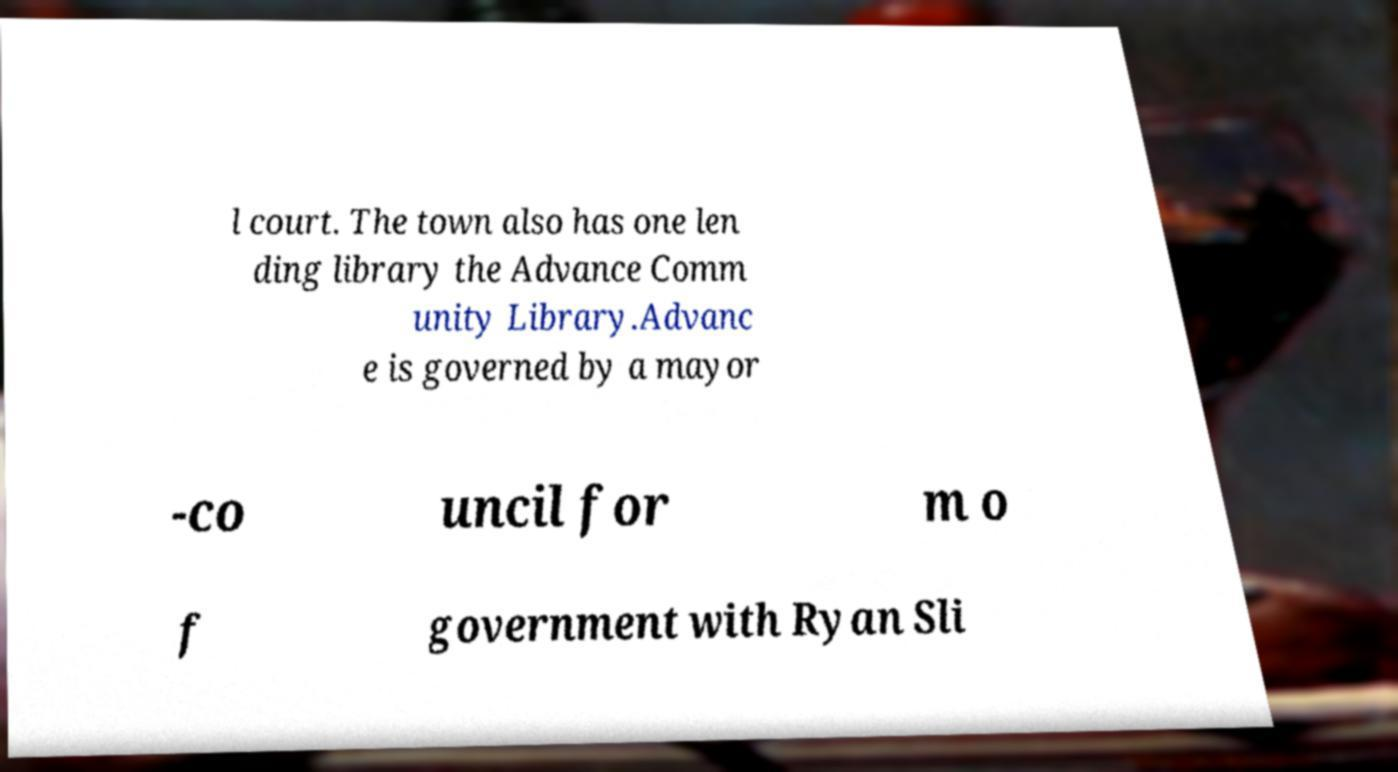Could you assist in decoding the text presented in this image and type it out clearly? l court. The town also has one len ding library the Advance Comm unity Library.Advanc e is governed by a mayor -co uncil for m o f government with Ryan Sli 